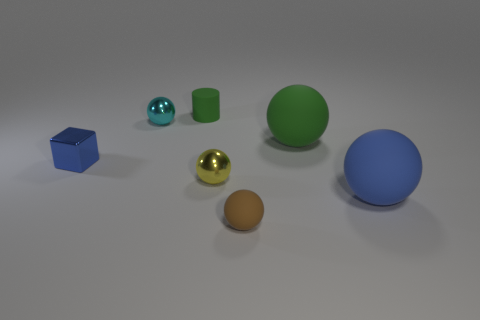There is a tiny rubber object to the right of the tiny metallic ball on the right side of the tiny cyan object; what is its shape?
Your response must be concise. Sphere. There is a thing that is on the left side of the large blue rubber ball and to the right of the brown matte ball; what shape is it?
Give a very brief answer. Sphere. What number of things are small yellow matte cubes or things that are behind the big blue rubber thing?
Provide a succinct answer. 5. What is the material of the tiny cyan object that is the same shape as the small yellow thing?
Your response must be concise. Metal. Is there any other thing that has the same material as the small brown ball?
Provide a short and direct response. Yes. There is a sphere that is both behind the yellow sphere and on the right side of the tiny green matte cylinder; what is it made of?
Make the answer very short. Rubber. What number of tiny yellow things are the same shape as the tiny blue metal object?
Give a very brief answer. 0. What is the color of the large matte thing in front of the tiny shiny thing that is to the right of the tiny cylinder?
Provide a succinct answer. Blue. Are there the same number of green matte objects on the right side of the small yellow ball and small cyan spheres?
Your answer should be very brief. Yes. Is there a block of the same size as the blue shiny thing?
Your response must be concise. No. 